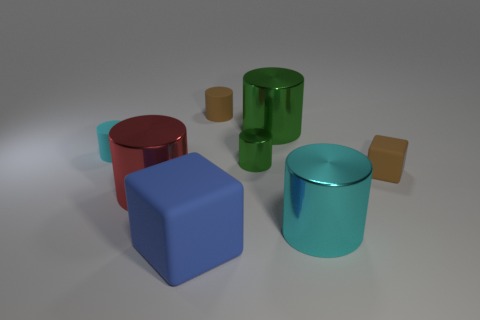How many other objects are there of the same color as the tiny metallic thing?
Your answer should be compact. 1. How many balls are small cyan metal objects or cyan rubber objects?
Your answer should be very brief. 0. What color is the large matte block that is in front of the small matte cylinder on the left side of the red thing?
Offer a very short reply. Blue. The red shiny thing is what shape?
Provide a short and direct response. Cylinder. There is a rubber cylinder that is in front of the brown matte cylinder; is it the same size as the big blue rubber block?
Provide a succinct answer. No. Is there another large thing that has the same material as the red thing?
Offer a very short reply. Yes. What number of objects are large cylinders that are to the left of the blue rubber object or large red cylinders?
Provide a succinct answer. 1. Are there any big red shiny cylinders?
Provide a succinct answer. Yes. What shape is the matte object that is both in front of the tiny cyan cylinder and behind the cyan metallic cylinder?
Offer a very short reply. Cube. How big is the blue rubber object that is in front of the cyan metallic cylinder?
Offer a terse response. Large. 